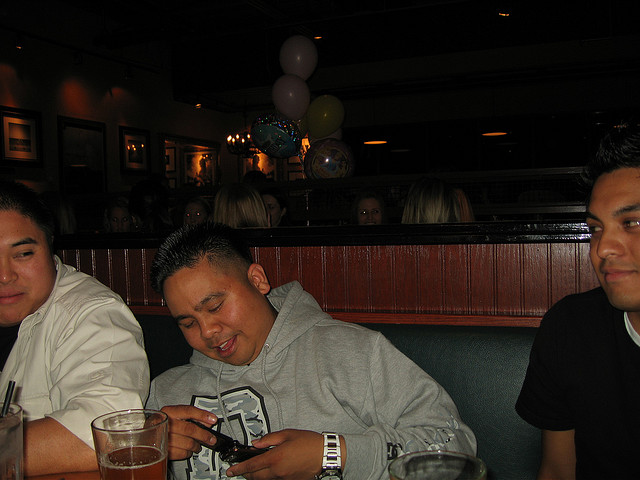<image>What is the design on the shirt behind the man? It is ambiguous to know the design on the shirt behind the man as it is not clearly visible. It might have a letter or writing. What drink is he making? I am not sure what drink he is making. It could be beer or vodka, or there could be no drink at all. What is the date of this photo? It is unknown what the date of the photo is. It doesn't seem to be indicated in the image. What drink is he making? It is ambiguous what drink he is making. It can be either beer or vodka. What is the design on the shirt behind the man? I am not sure what is the design on the shirt behind the man. It is not possible to see or determine the design. What is the date of this photo? I am not sure what is the date of this photo. It can be seen '2010', '2016', 'unknown', 'may 3 2007', 'no date', 'december 2012', '2011', 'october 1st', 'no date' or '2006'. 